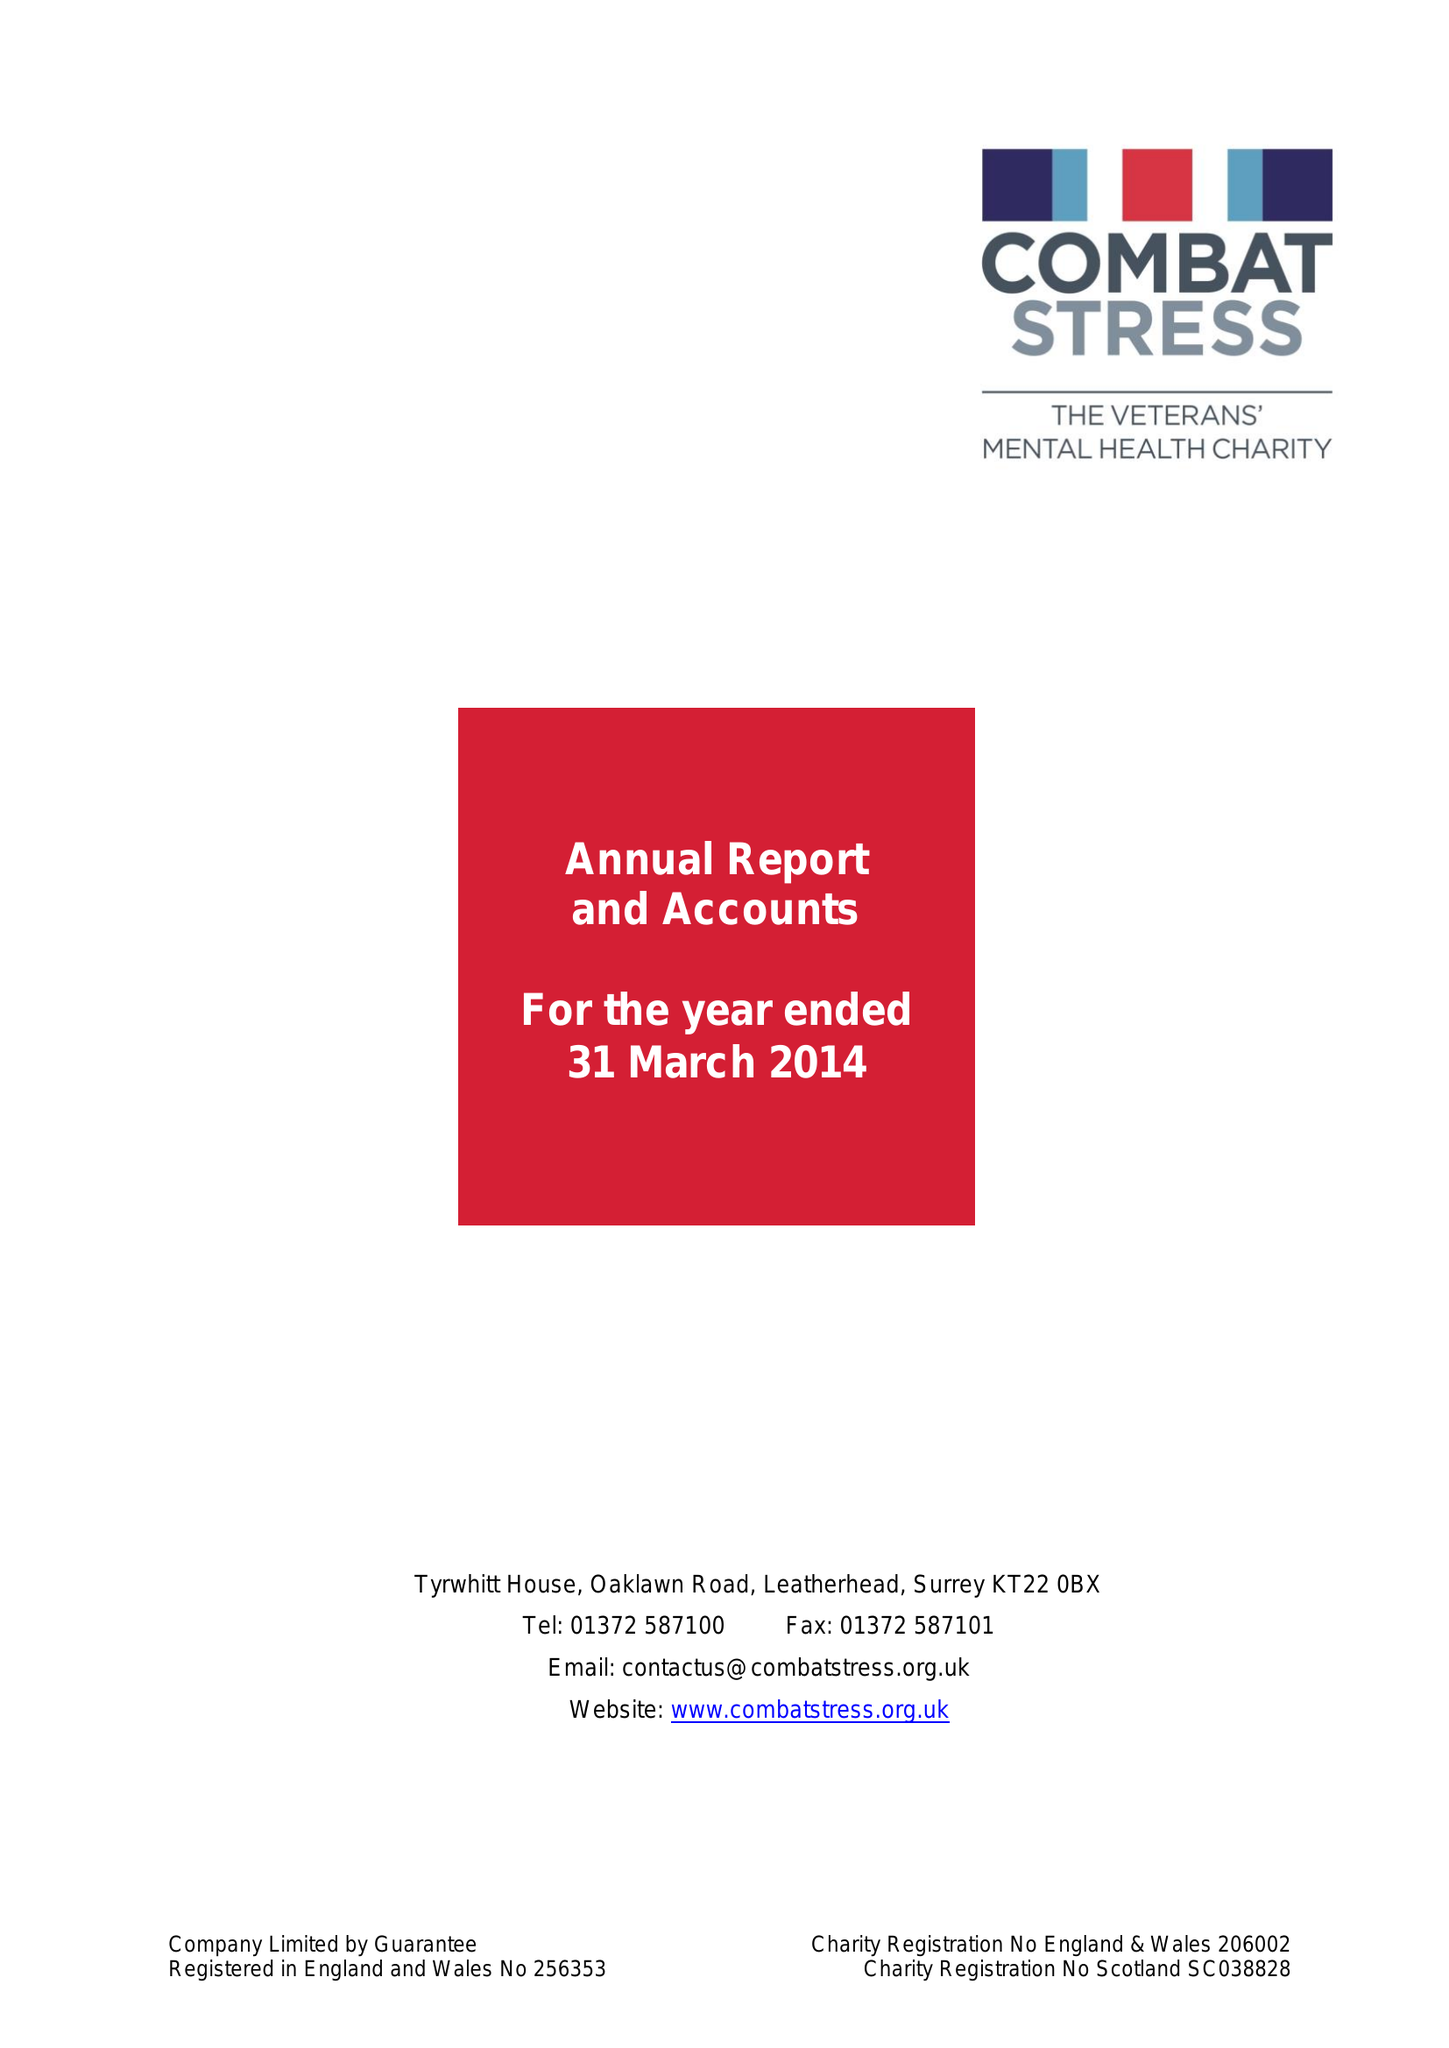What is the value for the charity_number?
Answer the question using a single word or phrase. 206002 